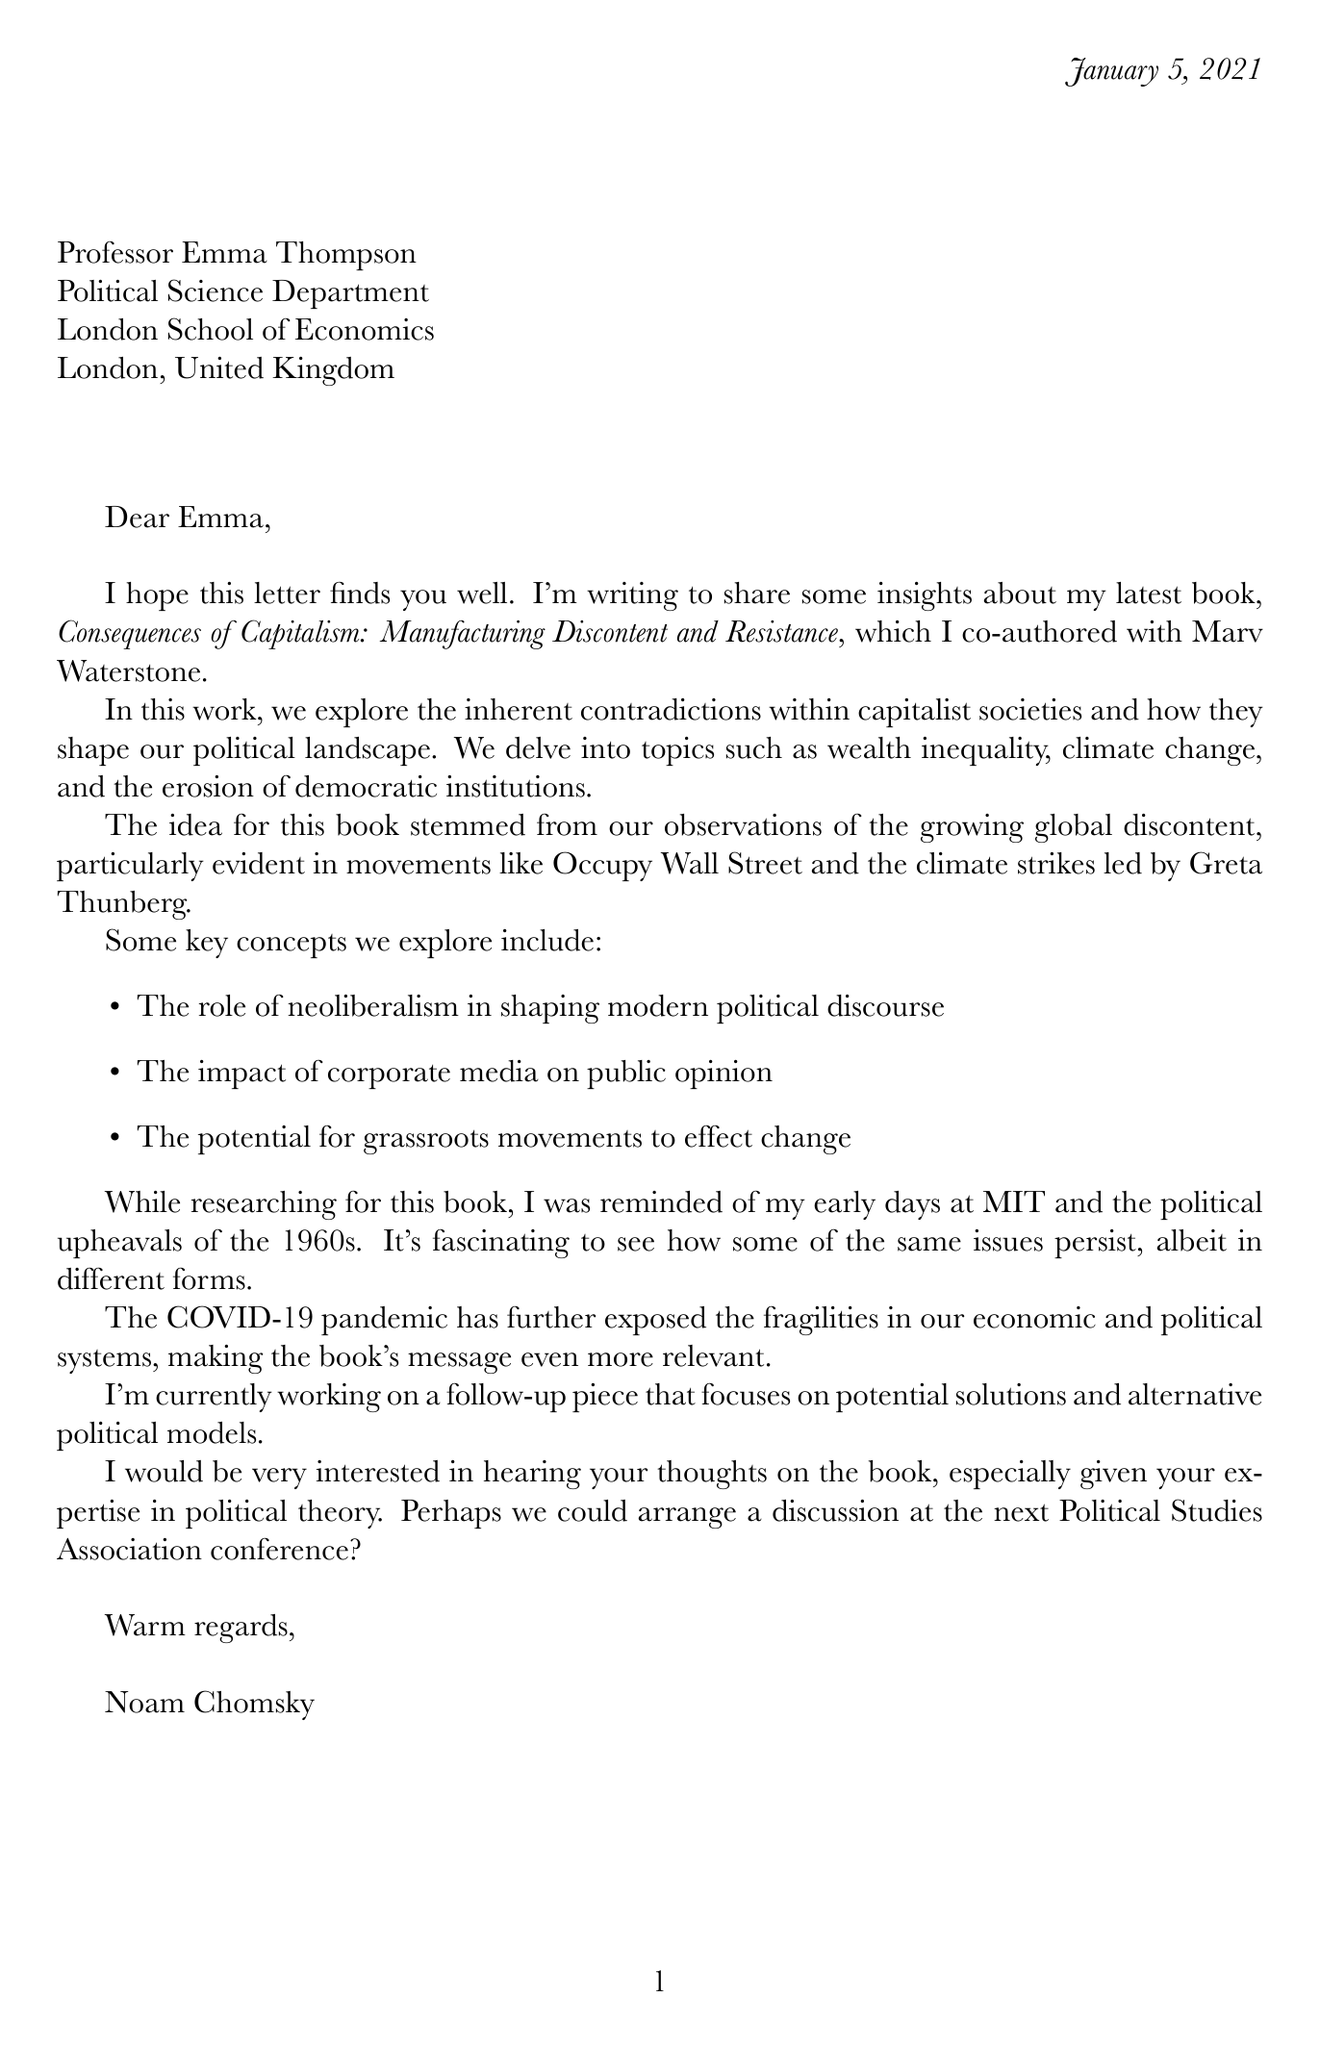What is the title of Noam Chomsky's latest book? The title of the book is mentioned in the introduction as "Consequences of Capitalism: Manufacturing Discontent and Resistance."
Answer: Consequences of Capitalism: Manufacturing Discontent and Resistance Who is the co-author of the latest book? The letter states that the book was co-authored with Marv Waterstone.
Answer: Marv Waterstone When was the book published? The publication date is noted at the top of the document as January 5, 2021.
Answer: January 5, 2021 What are some key topics discussed in the book? The letter lists topics such as wealth inequality, climate change, and the erosion of democratic institutions.
Answer: Wealth inequality, climate change, and the erosion of democratic institutions What movement inspired the idea for the book? The letter mentions that the idea stemmed from observations of movements like Occupy Wall Street and climate strikes led by Greta Thunberg.
Answer: Occupy Wall Street What does Chomsky plan to work on next? The letter mentions Chomsky is working on a follow-up piece focusing on potential solutions and alternative political models.
Answer: Potential solutions and alternative political models What does Chomsky reference from his early days? In the letter, he refers to the political upheavals of the 1960s during his early days at MIT.
Answer: Political upheavals of the 1960s What is the main purpose of this letter? The letter aims to share insights about the latest book and invite discussion on the book’s themes and concepts.
Answer: Share insights about the latest book 